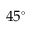<formula> <loc_0><loc_0><loc_500><loc_500>4 5 ^ { \circ }</formula> 